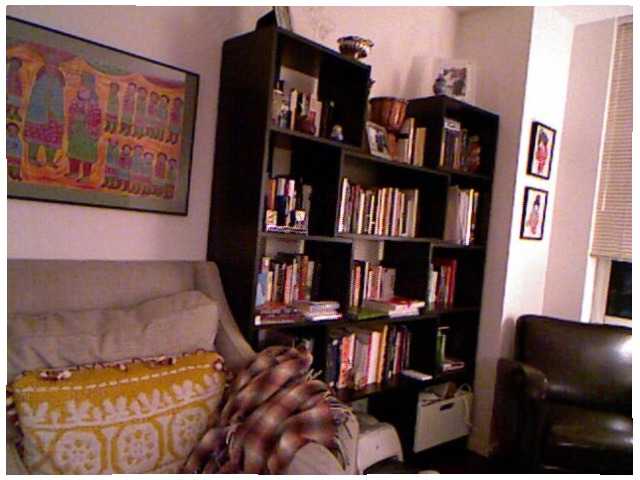<image>
Is the picture under the dvd? No. The picture is not positioned under the dvd. The vertical relationship between these objects is different. Is the books on the cupboard? Yes. Looking at the image, I can see the books is positioned on top of the cupboard, with the cupboard providing support. 